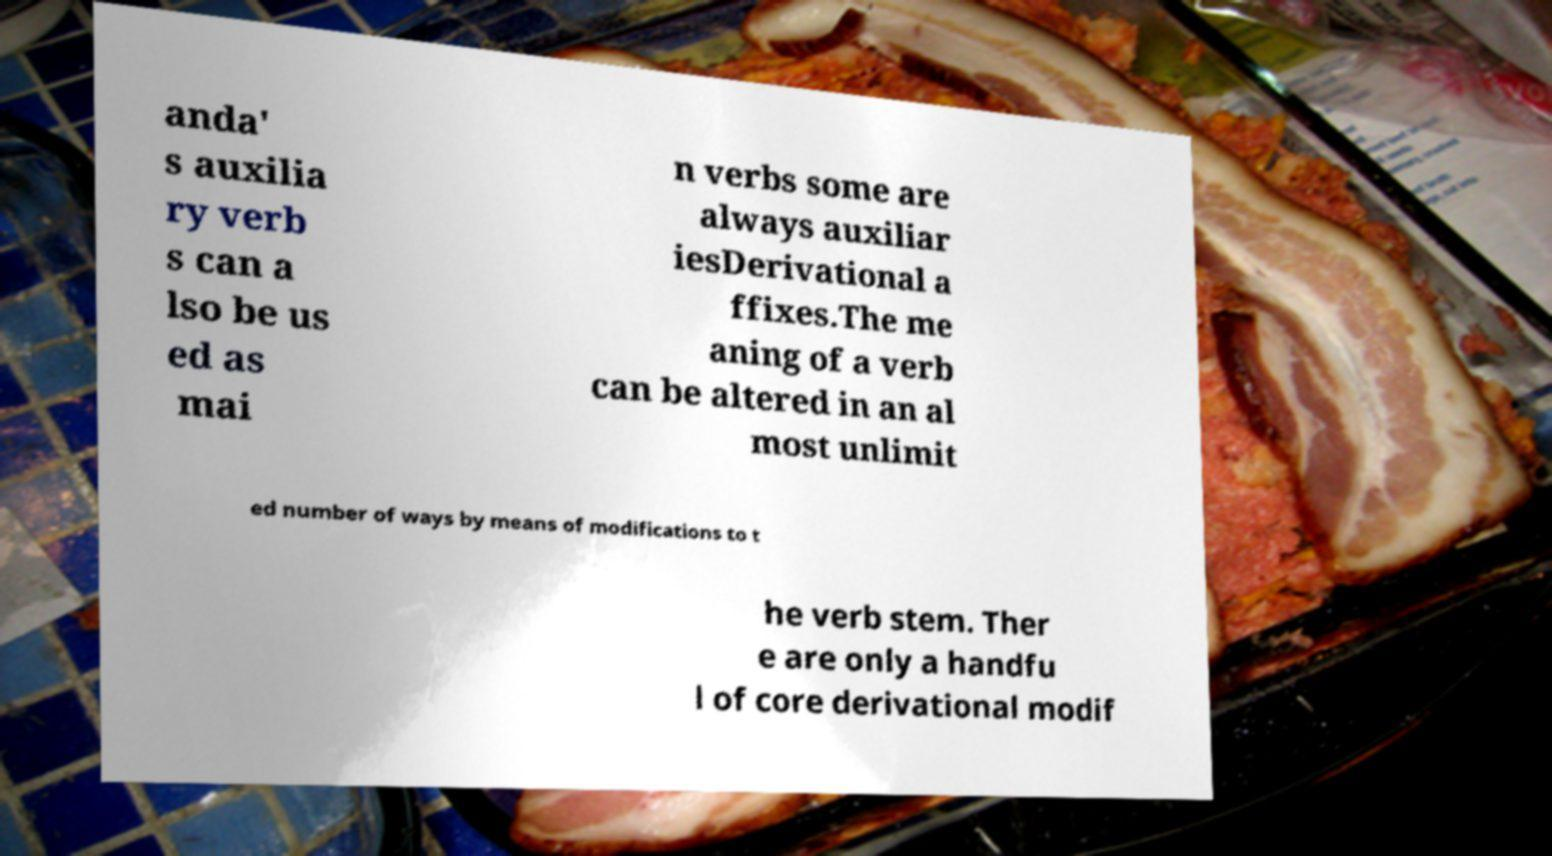I need the written content from this picture converted into text. Can you do that? anda' s auxilia ry verb s can a lso be us ed as mai n verbs some are always auxiliar iesDerivational a ffixes.The me aning of a verb can be altered in an al most unlimit ed number of ways by means of modifications to t he verb stem. Ther e are only a handfu l of core derivational modif 